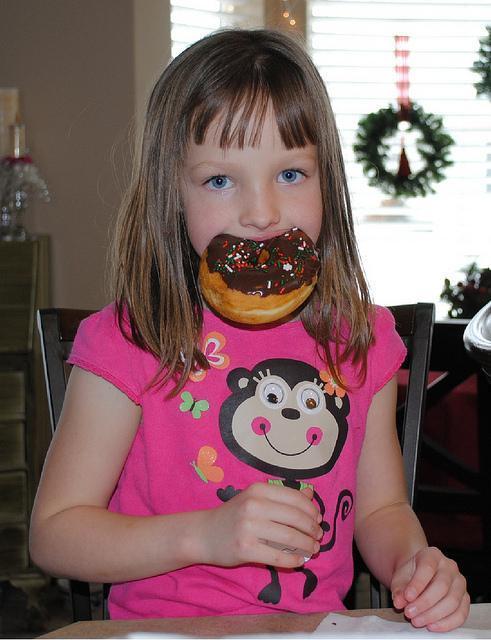How many bottles are in the photo?
Give a very brief answer. 1. How many dining tables are there?
Give a very brief answer. 1. 